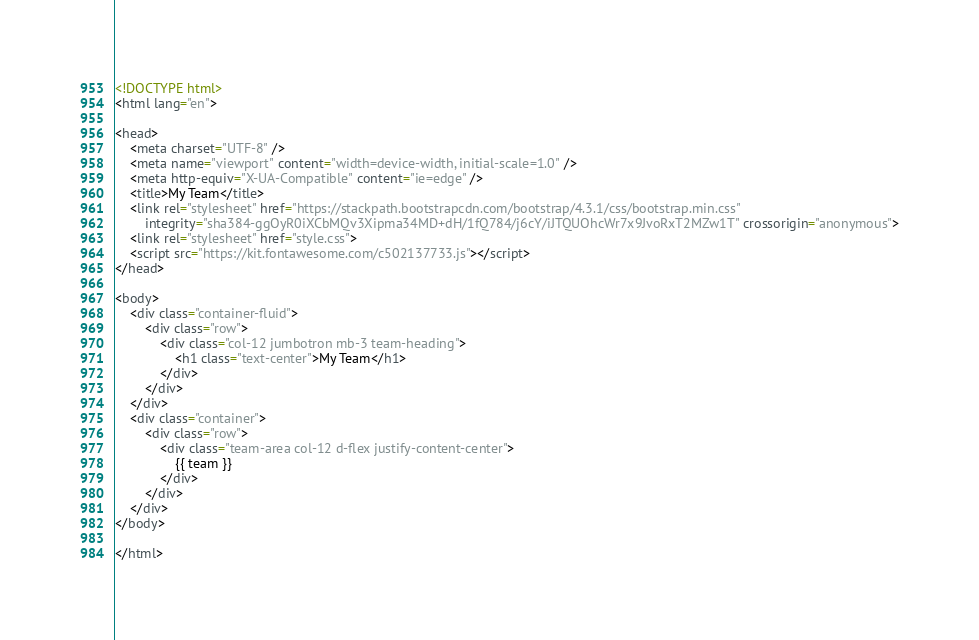Convert code to text. <code><loc_0><loc_0><loc_500><loc_500><_HTML_>
<!DOCTYPE html>
<html lang="en">

<head>
    <meta charset="UTF-8" />
    <meta name="viewport" content="width=device-width, initial-scale=1.0" />
    <meta http-equiv="X-UA-Compatible" content="ie=edge" />
    <title>My Team</title>
    <link rel="stylesheet" href="https://stackpath.bootstrapcdn.com/bootstrap/4.3.1/css/bootstrap.min.css"
        integrity="sha384-ggOyR0iXCbMQv3Xipma34MD+dH/1fQ784/j6cY/iJTQUOhcWr7x9JvoRxT2MZw1T" crossorigin="anonymous">
    <link rel="stylesheet" href="style.css">
    <script src="https://kit.fontawesome.com/c502137733.js"></script>
</head>

<body>
    <div class="container-fluid">
        <div class="row">
            <div class="col-12 jumbotron mb-3 team-heading">
                <h1 class="text-center">My Team</h1>
            </div>
        </div>
    </div>
    <div class="container">
        <div class="row">
            <div class="team-area col-12 d-flex justify-content-center">
                {{ team }}
            </div>
        </div>
    </div>
</body>

</html></code> 